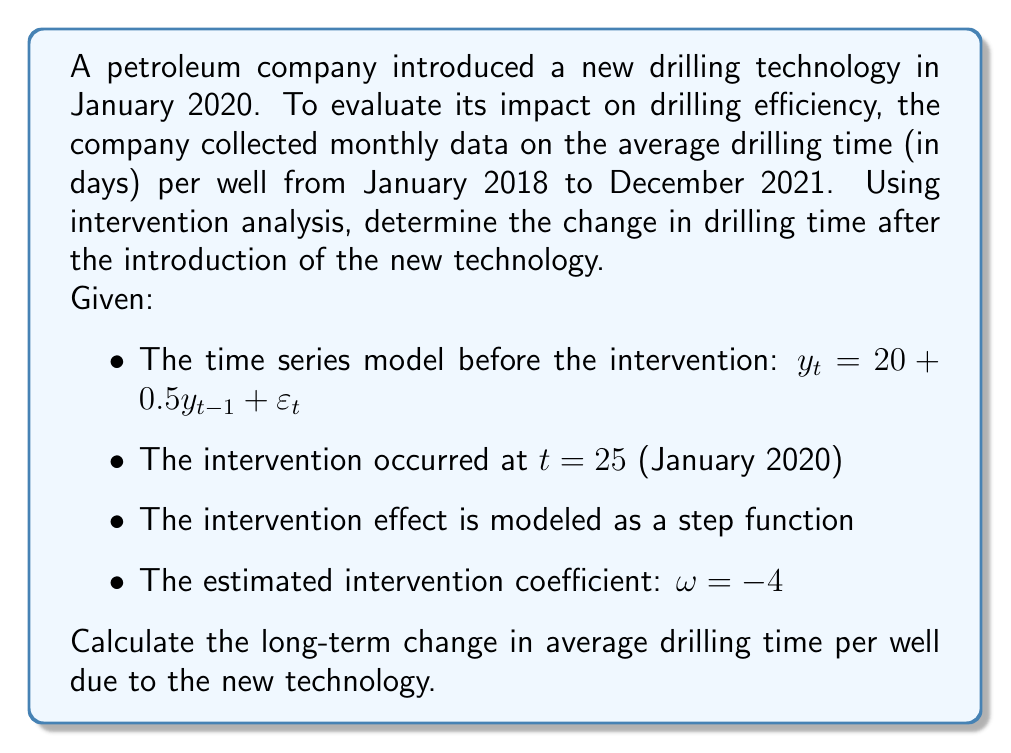Help me with this question. To solve this problem, we'll follow these steps:

1) The intervention model can be written as:

   $$y_t = 20 + 0.5y_{t-1} + \omega S_t + \varepsilon_t$$

   where $S_t$ is a step function that equals 0 before the intervention and 1 after.

2) The long-term effect of the intervention is calculated by finding the difference between the steady-state levels before and after the intervention.

3) Before the intervention, the steady-state level is:

   $$E(y) = 20 + 0.5E(y)$$
   $$0.5E(y) = 20$$
   $$E(y) = 40$$

4) After the intervention, the steady-state level is:

   $$E(y) = 20 + 0.5E(y) + \omega$$
   $$E(y) - 0.5E(y) = 20 + \omega$$
   $$0.5E(y) = 20 + \omega$$
   $$E(y) = 40 + 2\omega$$

5) The long-term change is the difference between these two steady-state levels:

   $$\text{Long-term change} = (40 + 2\omega) - 40 = 2\omega$$

6) Given $\omega = -4$, we can calculate the long-term change:

   $$\text{Long-term change} = 2 \times (-4) = -8$$

Therefore, the long-term change in average drilling time per well due to the new technology is a decrease of 8 days.
Answer: The long-term change in average drilling time per well due to the new technology is a decrease of 8 days. 